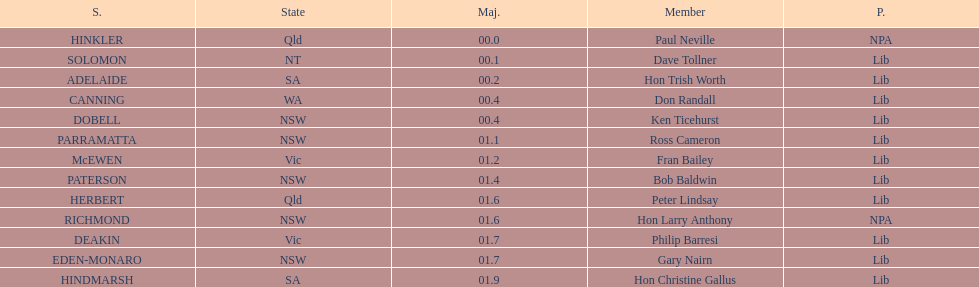Who is listed before don randall? Hon Trish Worth. 